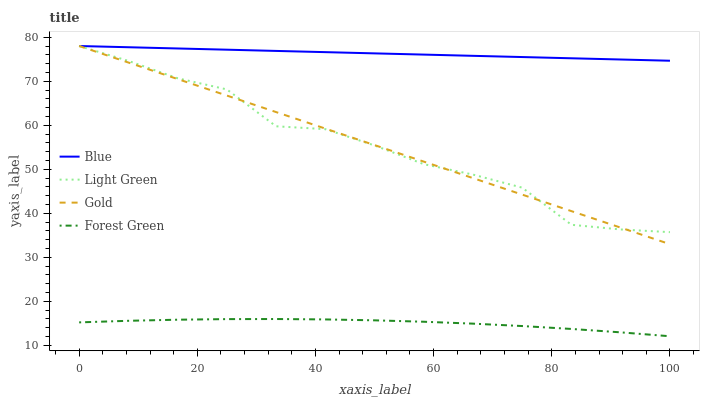Does Forest Green have the minimum area under the curve?
Answer yes or no. Yes. Does Blue have the maximum area under the curve?
Answer yes or no. Yes. Does Gold have the minimum area under the curve?
Answer yes or no. No. Does Gold have the maximum area under the curve?
Answer yes or no. No. Is Gold the smoothest?
Answer yes or no. Yes. Is Light Green the roughest?
Answer yes or no. Yes. Is Forest Green the smoothest?
Answer yes or no. No. Is Forest Green the roughest?
Answer yes or no. No. Does Forest Green have the lowest value?
Answer yes or no. Yes. Does Gold have the lowest value?
Answer yes or no. No. Does Light Green have the highest value?
Answer yes or no. Yes. Does Forest Green have the highest value?
Answer yes or no. No. Is Forest Green less than Blue?
Answer yes or no. Yes. Is Light Green greater than Forest Green?
Answer yes or no. Yes. Does Light Green intersect Blue?
Answer yes or no. Yes. Is Light Green less than Blue?
Answer yes or no. No. Is Light Green greater than Blue?
Answer yes or no. No. Does Forest Green intersect Blue?
Answer yes or no. No. 